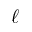<formula> <loc_0><loc_0><loc_500><loc_500>\ell</formula> 